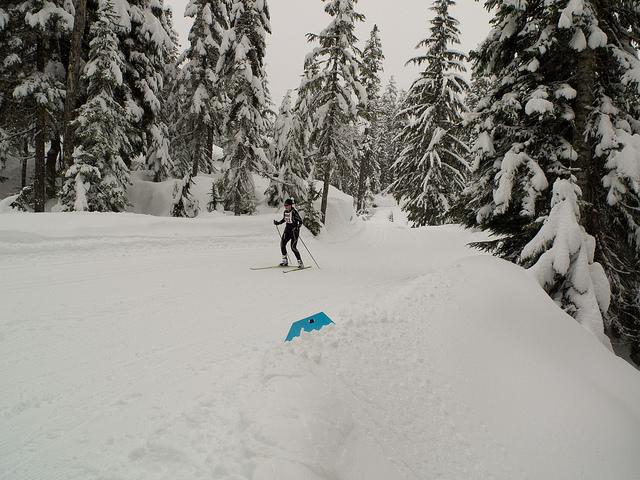What color do you notice?
Write a very short answer. Blue. Have you ever had this much snow where you live?
Be succinct. Yes. What geological structure is behind the man?
Quick response, please. Mountain. What color are the flags marking the trail?
Keep it brief. Blue. Is this fresh, newly fallen snow?
Answer briefly. Yes. Are the skier's arms down?
Quick response, please. Yes. Are the trees that are visible covered with snow?
Concise answer only. Yes. How many people are shown?
Concise answer only. 1. Is it hot over there?
Short answer required. No. Is this man flying through the air?
Be succinct. No. Is the skier going downhill?
Answer briefly. No. Is this a smooth slope?
Give a very brief answer. Yes. What style of home is this?
Write a very short answer. No home. Are there mountains in the background?
Concise answer only. No. 